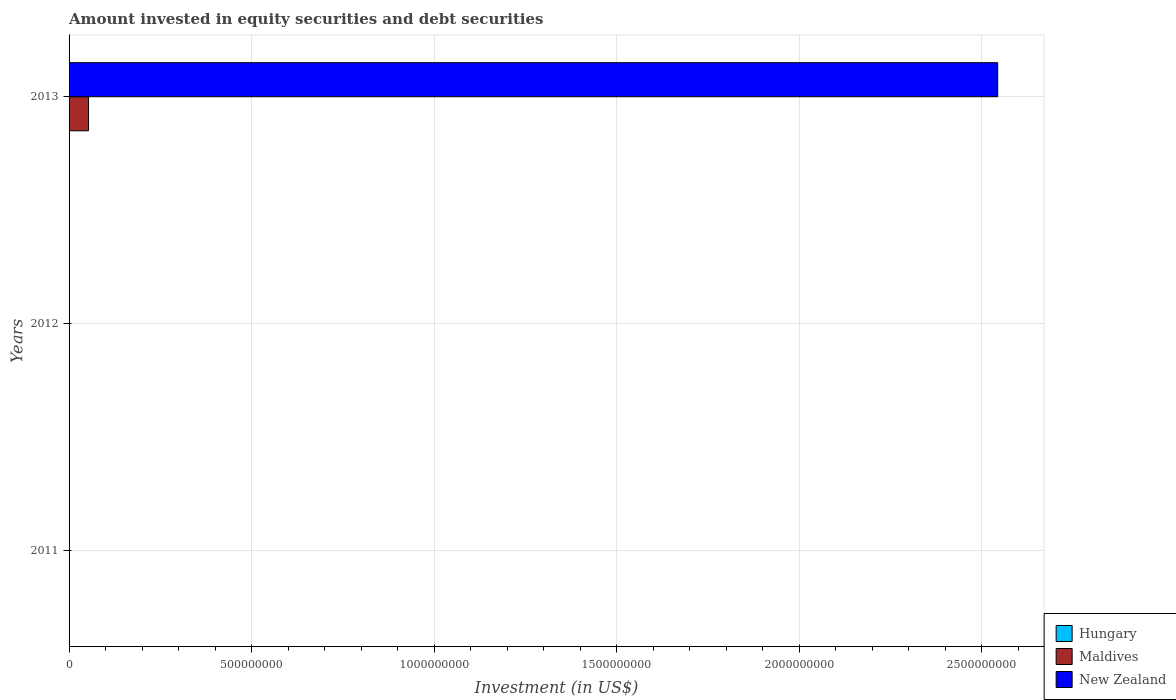How many different coloured bars are there?
Give a very brief answer. 2. How many bars are there on the 1st tick from the bottom?
Provide a short and direct response. 0. What is the amount invested in equity securities and debt securities in Hungary in 2011?
Provide a succinct answer. 0. Across all years, what is the maximum amount invested in equity securities and debt securities in New Zealand?
Provide a succinct answer. 2.54e+09. What is the average amount invested in equity securities and debt securities in New Zealand per year?
Offer a very short reply. 8.48e+08. In the year 2013, what is the difference between the amount invested in equity securities and debt securities in New Zealand and amount invested in equity securities and debt securities in Maldives?
Offer a terse response. 2.49e+09. In how many years, is the amount invested in equity securities and debt securities in New Zealand greater than 2200000000 US$?
Offer a very short reply. 1. What is the difference between the highest and the lowest amount invested in equity securities and debt securities in New Zealand?
Your answer should be very brief. 2.54e+09. In how many years, is the amount invested in equity securities and debt securities in Maldives greater than the average amount invested in equity securities and debt securities in Maldives taken over all years?
Offer a very short reply. 1. Is it the case that in every year, the sum of the amount invested in equity securities and debt securities in Maldives and amount invested in equity securities and debt securities in New Zealand is greater than the amount invested in equity securities and debt securities in Hungary?
Your answer should be very brief. No. How many bars are there?
Offer a very short reply. 2. Are the values on the major ticks of X-axis written in scientific E-notation?
Your answer should be compact. No. Does the graph contain any zero values?
Provide a succinct answer. Yes. Where does the legend appear in the graph?
Offer a very short reply. Bottom right. How many legend labels are there?
Your answer should be very brief. 3. How are the legend labels stacked?
Keep it short and to the point. Vertical. What is the title of the graph?
Offer a terse response. Amount invested in equity securities and debt securities. Does "Egypt, Arab Rep." appear as one of the legend labels in the graph?
Your answer should be compact. No. What is the label or title of the X-axis?
Your answer should be compact. Investment (in US$). What is the label or title of the Y-axis?
Give a very brief answer. Years. What is the Investment (in US$) in Hungary in 2011?
Offer a terse response. 0. What is the Investment (in US$) of New Zealand in 2012?
Offer a very short reply. 0. What is the Investment (in US$) in Maldives in 2013?
Your answer should be very brief. 5.33e+07. What is the Investment (in US$) of New Zealand in 2013?
Your answer should be compact. 2.54e+09. Across all years, what is the maximum Investment (in US$) in Maldives?
Provide a succinct answer. 5.33e+07. Across all years, what is the maximum Investment (in US$) of New Zealand?
Ensure brevity in your answer.  2.54e+09. Across all years, what is the minimum Investment (in US$) of New Zealand?
Your answer should be compact. 0. What is the total Investment (in US$) in Hungary in the graph?
Make the answer very short. 0. What is the total Investment (in US$) of Maldives in the graph?
Offer a very short reply. 5.33e+07. What is the total Investment (in US$) in New Zealand in the graph?
Give a very brief answer. 2.54e+09. What is the average Investment (in US$) of Maldives per year?
Make the answer very short. 1.78e+07. What is the average Investment (in US$) in New Zealand per year?
Your response must be concise. 8.48e+08. In the year 2013, what is the difference between the Investment (in US$) in Maldives and Investment (in US$) in New Zealand?
Make the answer very short. -2.49e+09. What is the difference between the highest and the lowest Investment (in US$) in Maldives?
Keep it short and to the point. 5.33e+07. What is the difference between the highest and the lowest Investment (in US$) of New Zealand?
Provide a succinct answer. 2.54e+09. 